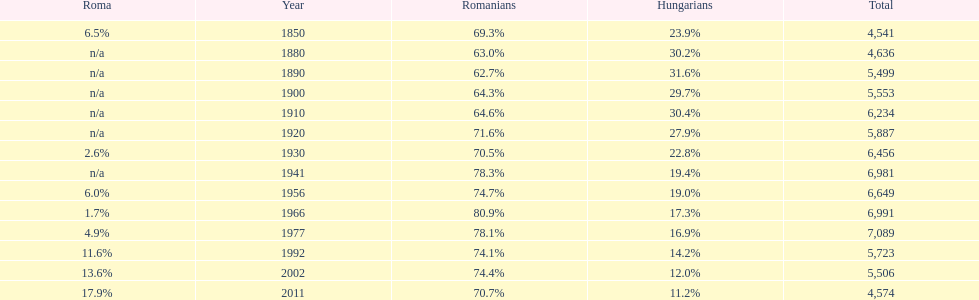In what year was there the largest percentage of hungarians? 1890. 